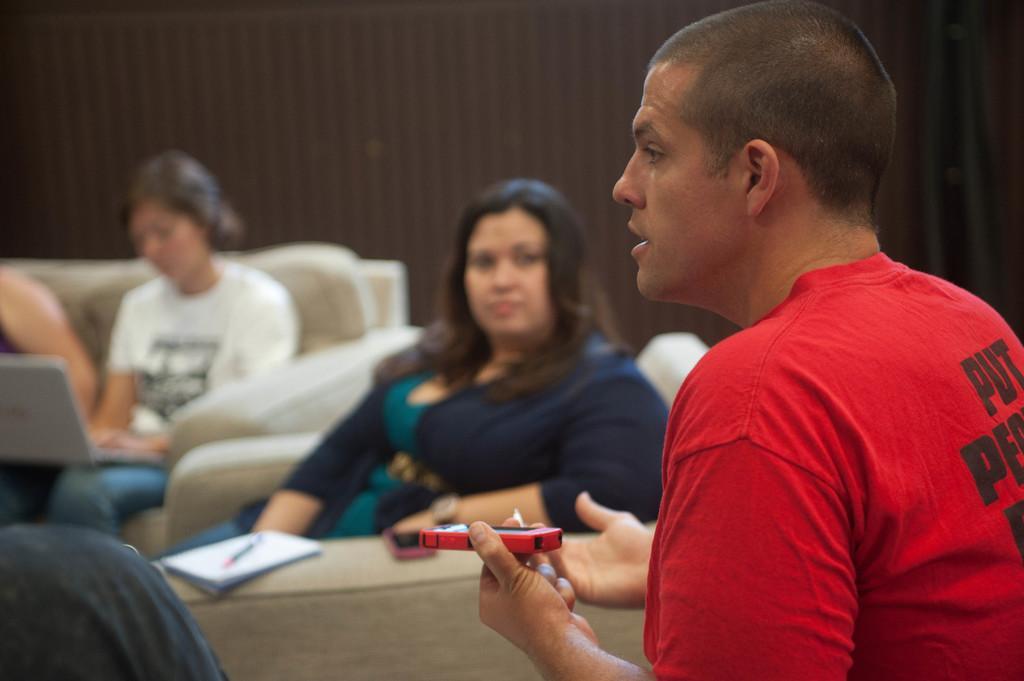Describe this image in one or two sentences. In this picture we can see a woman sitting on a chair, wearing a white t-shirt and there is a laptop. Beside to her we can see a woman sitting on a chair and there is a book and a pen on the chair. On the right side we can see a man wearing a red t-shirt and he is holding a red color object. 